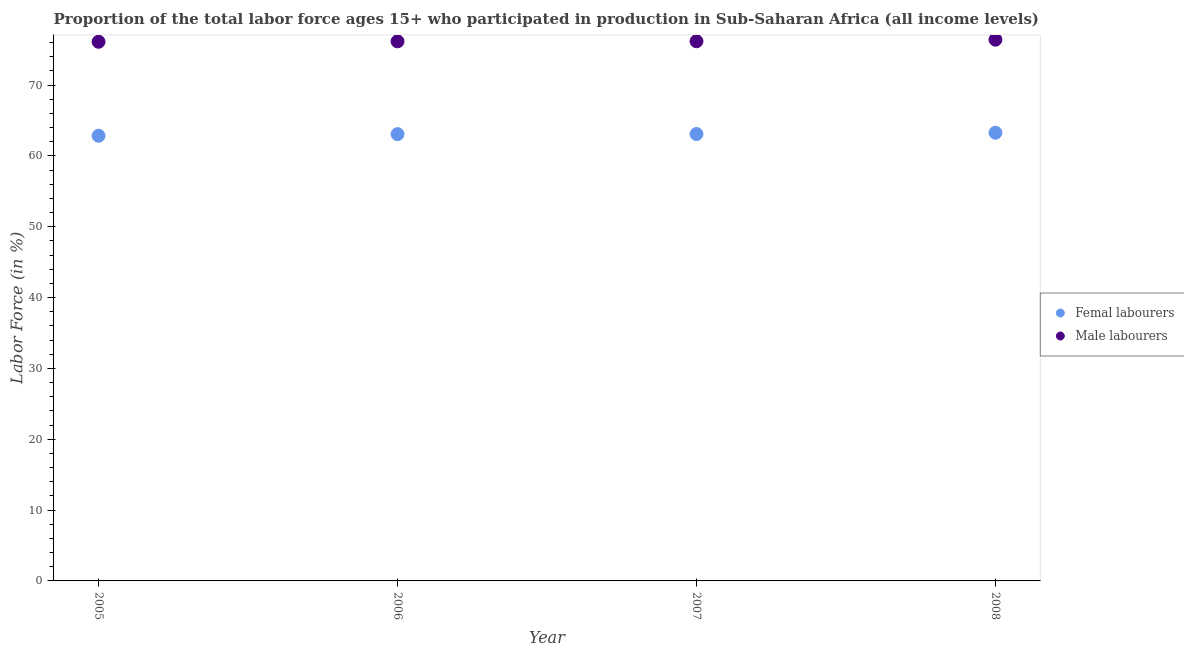How many different coloured dotlines are there?
Keep it short and to the point. 2. Is the number of dotlines equal to the number of legend labels?
Your answer should be compact. Yes. What is the percentage of male labour force in 2008?
Provide a short and direct response. 76.41. Across all years, what is the maximum percentage of female labor force?
Your answer should be very brief. 63.27. Across all years, what is the minimum percentage of female labor force?
Provide a short and direct response. 62.85. In which year was the percentage of male labour force minimum?
Your answer should be very brief. 2005. What is the total percentage of male labour force in the graph?
Ensure brevity in your answer.  304.9. What is the difference between the percentage of male labour force in 2007 and that in 2008?
Keep it short and to the point. -0.22. What is the difference between the percentage of female labor force in 2006 and the percentage of male labour force in 2005?
Make the answer very short. -13.04. What is the average percentage of female labor force per year?
Provide a short and direct response. 63.07. In the year 2005, what is the difference between the percentage of female labor force and percentage of male labour force?
Make the answer very short. -13.27. What is the ratio of the percentage of female labor force in 2005 to that in 2006?
Provide a succinct answer. 1. Is the percentage of male labour force in 2005 less than that in 2007?
Offer a very short reply. Yes. What is the difference between the highest and the second highest percentage of male labour force?
Keep it short and to the point. 0.22. What is the difference between the highest and the lowest percentage of female labor force?
Provide a succinct answer. 0.43. Does the percentage of female labor force monotonically increase over the years?
Ensure brevity in your answer.  Yes. How many years are there in the graph?
Your response must be concise. 4. What is the difference between two consecutive major ticks on the Y-axis?
Provide a succinct answer. 10. Does the graph contain any zero values?
Keep it short and to the point. No. How many legend labels are there?
Your answer should be very brief. 2. What is the title of the graph?
Provide a short and direct response. Proportion of the total labor force ages 15+ who participated in production in Sub-Saharan Africa (all income levels). What is the label or title of the Y-axis?
Your response must be concise. Labor Force (in %). What is the Labor Force (in %) in Femal labourers in 2005?
Make the answer very short. 62.85. What is the Labor Force (in %) in Male labourers in 2005?
Your answer should be very brief. 76.12. What is the Labor Force (in %) in Femal labourers in 2006?
Keep it short and to the point. 63.08. What is the Labor Force (in %) in Male labourers in 2006?
Provide a succinct answer. 76.18. What is the Labor Force (in %) in Femal labourers in 2007?
Your answer should be very brief. 63.1. What is the Labor Force (in %) of Male labourers in 2007?
Make the answer very short. 76.19. What is the Labor Force (in %) in Femal labourers in 2008?
Your response must be concise. 63.27. What is the Labor Force (in %) in Male labourers in 2008?
Keep it short and to the point. 76.41. Across all years, what is the maximum Labor Force (in %) of Femal labourers?
Provide a short and direct response. 63.27. Across all years, what is the maximum Labor Force (in %) of Male labourers?
Offer a terse response. 76.41. Across all years, what is the minimum Labor Force (in %) of Femal labourers?
Offer a terse response. 62.85. Across all years, what is the minimum Labor Force (in %) of Male labourers?
Your answer should be compact. 76.12. What is the total Labor Force (in %) of Femal labourers in the graph?
Provide a succinct answer. 252.3. What is the total Labor Force (in %) in Male labourers in the graph?
Your answer should be compact. 304.9. What is the difference between the Labor Force (in %) in Femal labourers in 2005 and that in 2006?
Your answer should be very brief. -0.23. What is the difference between the Labor Force (in %) of Male labourers in 2005 and that in 2006?
Your answer should be very brief. -0.06. What is the difference between the Labor Force (in %) of Femal labourers in 2005 and that in 2007?
Make the answer very short. -0.25. What is the difference between the Labor Force (in %) of Male labourers in 2005 and that in 2007?
Make the answer very short. -0.08. What is the difference between the Labor Force (in %) of Femal labourers in 2005 and that in 2008?
Provide a succinct answer. -0.43. What is the difference between the Labor Force (in %) in Male labourers in 2005 and that in 2008?
Provide a succinct answer. -0.3. What is the difference between the Labor Force (in %) in Femal labourers in 2006 and that in 2007?
Give a very brief answer. -0.02. What is the difference between the Labor Force (in %) in Male labourers in 2006 and that in 2007?
Keep it short and to the point. -0.02. What is the difference between the Labor Force (in %) of Femal labourers in 2006 and that in 2008?
Give a very brief answer. -0.19. What is the difference between the Labor Force (in %) in Male labourers in 2006 and that in 2008?
Provide a succinct answer. -0.23. What is the difference between the Labor Force (in %) in Femal labourers in 2007 and that in 2008?
Your response must be concise. -0.18. What is the difference between the Labor Force (in %) in Male labourers in 2007 and that in 2008?
Provide a short and direct response. -0.22. What is the difference between the Labor Force (in %) of Femal labourers in 2005 and the Labor Force (in %) of Male labourers in 2006?
Make the answer very short. -13.33. What is the difference between the Labor Force (in %) in Femal labourers in 2005 and the Labor Force (in %) in Male labourers in 2007?
Offer a very short reply. -13.35. What is the difference between the Labor Force (in %) of Femal labourers in 2005 and the Labor Force (in %) of Male labourers in 2008?
Your response must be concise. -13.57. What is the difference between the Labor Force (in %) in Femal labourers in 2006 and the Labor Force (in %) in Male labourers in 2007?
Your answer should be compact. -13.11. What is the difference between the Labor Force (in %) of Femal labourers in 2006 and the Labor Force (in %) of Male labourers in 2008?
Ensure brevity in your answer.  -13.33. What is the difference between the Labor Force (in %) of Femal labourers in 2007 and the Labor Force (in %) of Male labourers in 2008?
Make the answer very short. -13.32. What is the average Labor Force (in %) of Femal labourers per year?
Offer a terse response. 63.07. What is the average Labor Force (in %) in Male labourers per year?
Your answer should be very brief. 76.23. In the year 2005, what is the difference between the Labor Force (in %) of Femal labourers and Labor Force (in %) of Male labourers?
Offer a terse response. -13.27. In the year 2006, what is the difference between the Labor Force (in %) in Femal labourers and Labor Force (in %) in Male labourers?
Provide a short and direct response. -13.1. In the year 2007, what is the difference between the Labor Force (in %) in Femal labourers and Labor Force (in %) in Male labourers?
Provide a short and direct response. -13.1. In the year 2008, what is the difference between the Labor Force (in %) of Femal labourers and Labor Force (in %) of Male labourers?
Provide a short and direct response. -13.14. What is the ratio of the Labor Force (in %) in Femal labourers in 2005 to that in 2008?
Offer a terse response. 0.99. What is the ratio of the Labor Force (in %) in Femal labourers in 2006 to that in 2007?
Your answer should be compact. 1. What is the ratio of the Labor Force (in %) of Femal labourers in 2007 to that in 2008?
Ensure brevity in your answer.  1. What is the ratio of the Labor Force (in %) of Male labourers in 2007 to that in 2008?
Keep it short and to the point. 1. What is the difference between the highest and the second highest Labor Force (in %) of Femal labourers?
Give a very brief answer. 0.18. What is the difference between the highest and the second highest Labor Force (in %) of Male labourers?
Give a very brief answer. 0.22. What is the difference between the highest and the lowest Labor Force (in %) in Femal labourers?
Provide a short and direct response. 0.43. What is the difference between the highest and the lowest Labor Force (in %) in Male labourers?
Offer a terse response. 0.3. 